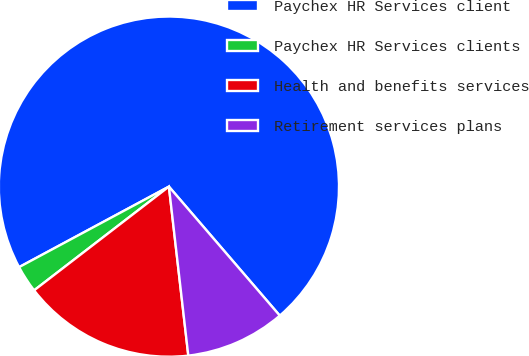Convert chart to OTSL. <chart><loc_0><loc_0><loc_500><loc_500><pie_chart><fcel>Paychex HR Services client<fcel>Paychex HR Services clients<fcel>Health and benefits services<fcel>Retirement services plans<nl><fcel>71.55%<fcel>2.59%<fcel>16.38%<fcel>9.48%<nl></chart> 